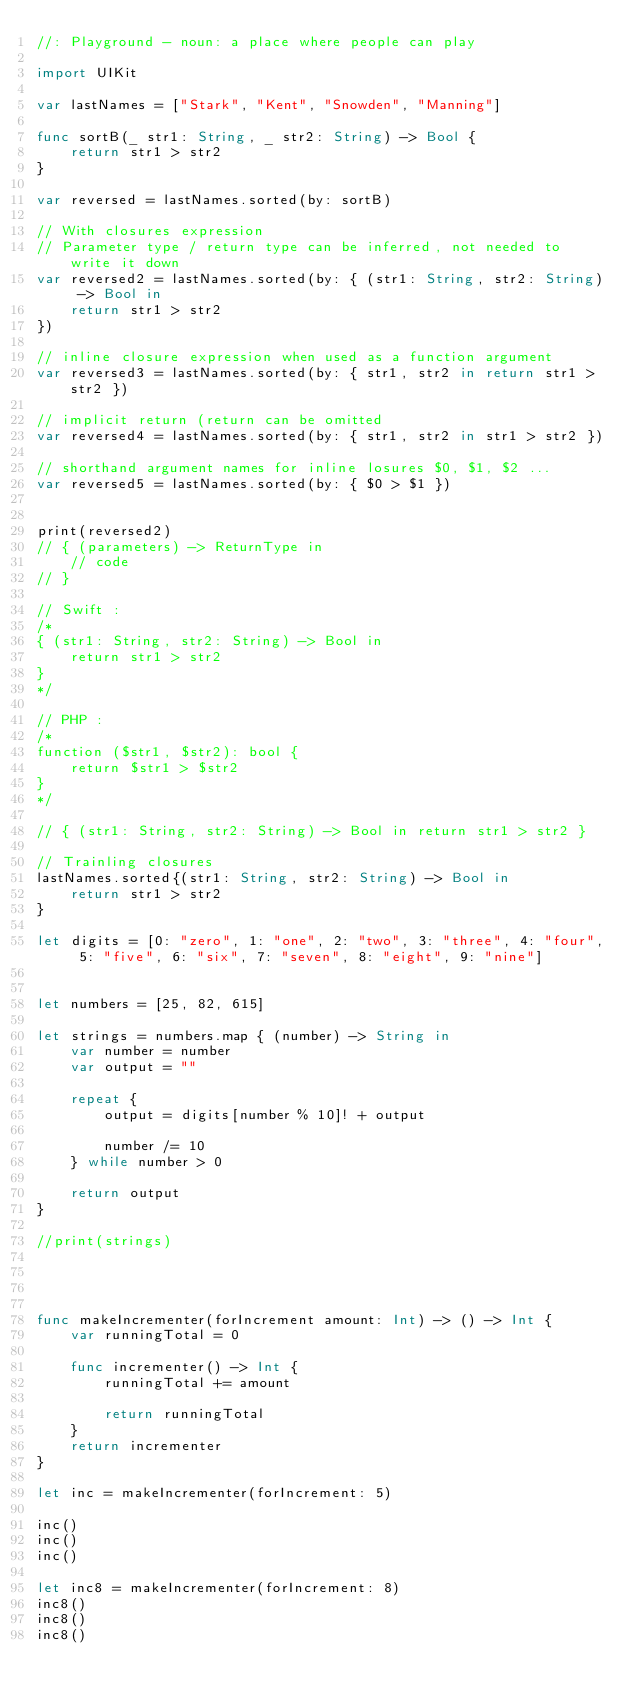Convert code to text. <code><loc_0><loc_0><loc_500><loc_500><_Swift_>//: Playground - noun: a place where people can play

import UIKit

var lastNames = ["Stark", "Kent", "Snowden", "Manning"]

func sortB(_ str1: String, _ str2: String) -> Bool {
    return str1 > str2
}

var reversed = lastNames.sorted(by: sortB)

// With closures expression
// Parameter type / return type can be inferred, not needed to write it down
var reversed2 = lastNames.sorted(by: { (str1: String, str2: String) -> Bool in
    return str1 > str2
})

// inline closure expression when used as a function argument
var reversed3 = lastNames.sorted(by: { str1, str2 in return str1 > str2 })

// implicit return (return can be omitted
var reversed4 = lastNames.sorted(by: { str1, str2 in str1 > str2 })

// shorthand argument names for inline losures $0, $1, $2 ...
var reversed5 = lastNames.sorted(by: { $0 > $1 })


print(reversed2)
// { (parameters) -> ReturnType in 
    // code
// }

// Swift :
/*
{ (str1: String, str2: String) -> Bool in
    return str1 > str2
}
*/

// PHP :
/*
function ($str1, $str2): bool {
    return $str1 > $str2
}
*/

// { (str1: String, str2: String) -> Bool in return str1 > str2 }

// Trainling closures
lastNames.sorted{(str1: String, str2: String) -> Bool in
    return str1 > str2
}

let digits = [0: "zero", 1: "one", 2: "two", 3: "three", 4: "four", 5: "five", 6: "six", 7: "seven", 8: "eight", 9: "nine"]


let numbers = [25, 82, 615]

let strings = numbers.map { (number) -> String in
    var number = number
    var output = ""
    
    repeat {
        output = digits[number % 10]! + output
        
        number /= 10
    } while number > 0
    
    return output
}

//print(strings)




func makeIncrementer(forIncrement amount: Int) -> () -> Int {
    var runningTotal = 0
    
    func incrementer() -> Int {
        runningTotal += amount
        
        return runningTotal
    }
    return incrementer
}

let inc = makeIncrementer(forIncrement: 5)

inc()
inc()
inc()

let inc8 = makeIncrementer(forIncrement: 8)
inc8()
inc8()
inc8()


</code> 